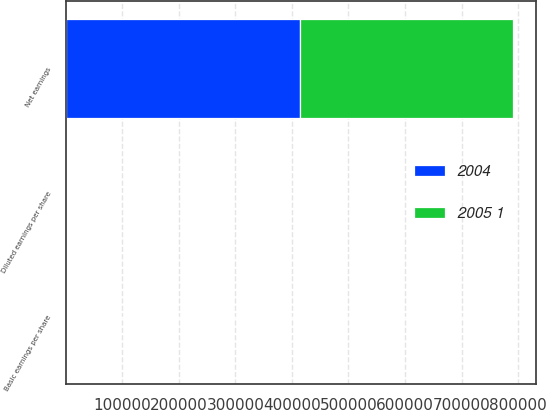Convert chart. <chart><loc_0><loc_0><loc_500><loc_500><stacked_bar_chart><ecel><fcel>Net earnings<fcel>Basic earnings per share<fcel>Diluted earnings per share<nl><fcel>2004<fcel>414421<fcel>6.19<fcel>6.13<nl><fcel>2005 1<fcel>376930<fcel>5.65<fcel>5.58<nl></chart> 